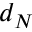Convert formula to latex. <formula><loc_0><loc_0><loc_500><loc_500>d _ { N }</formula> 